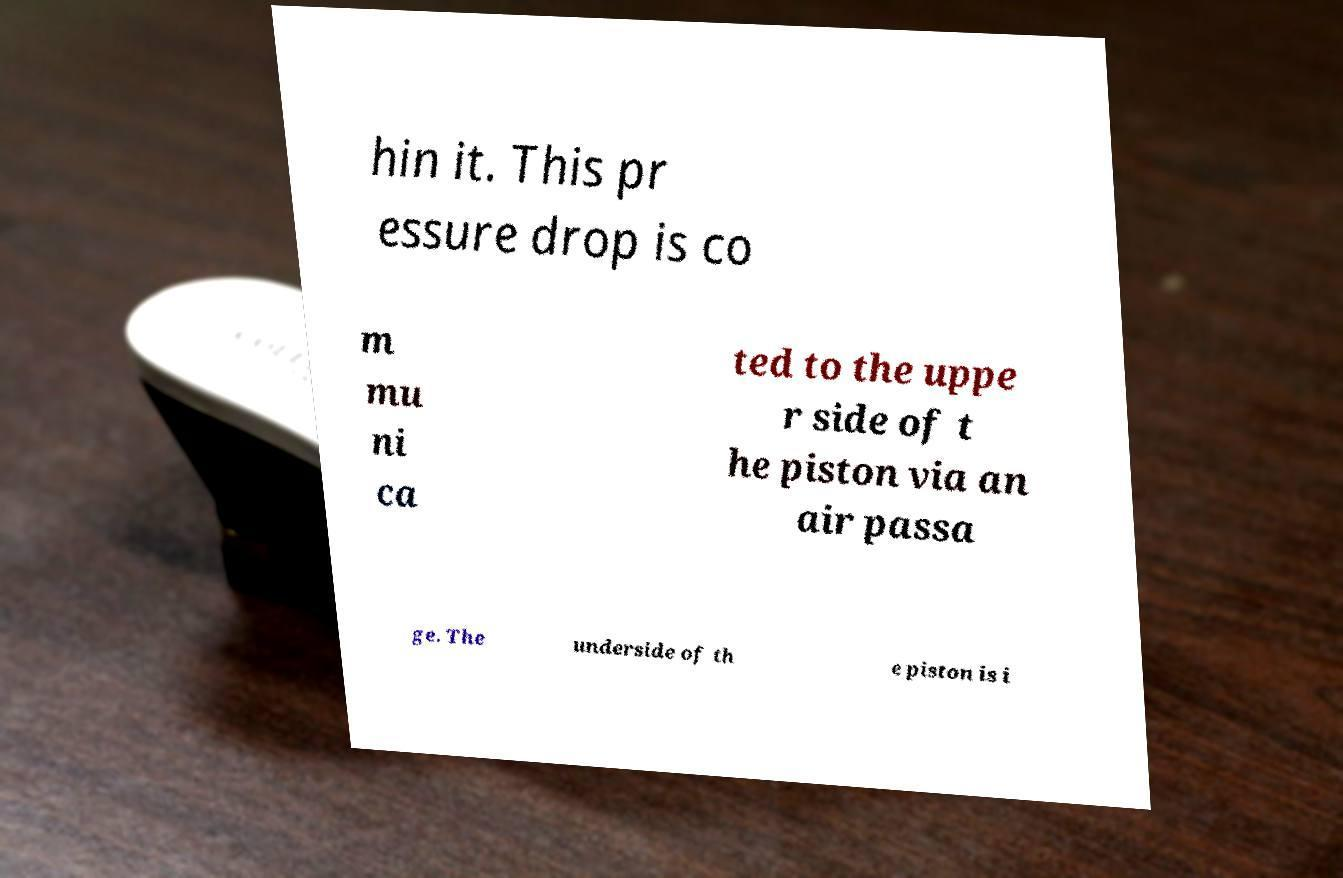What messages or text are displayed in this image? I need them in a readable, typed format. hin it. This pr essure drop is co m mu ni ca ted to the uppe r side of t he piston via an air passa ge. The underside of th e piston is i 